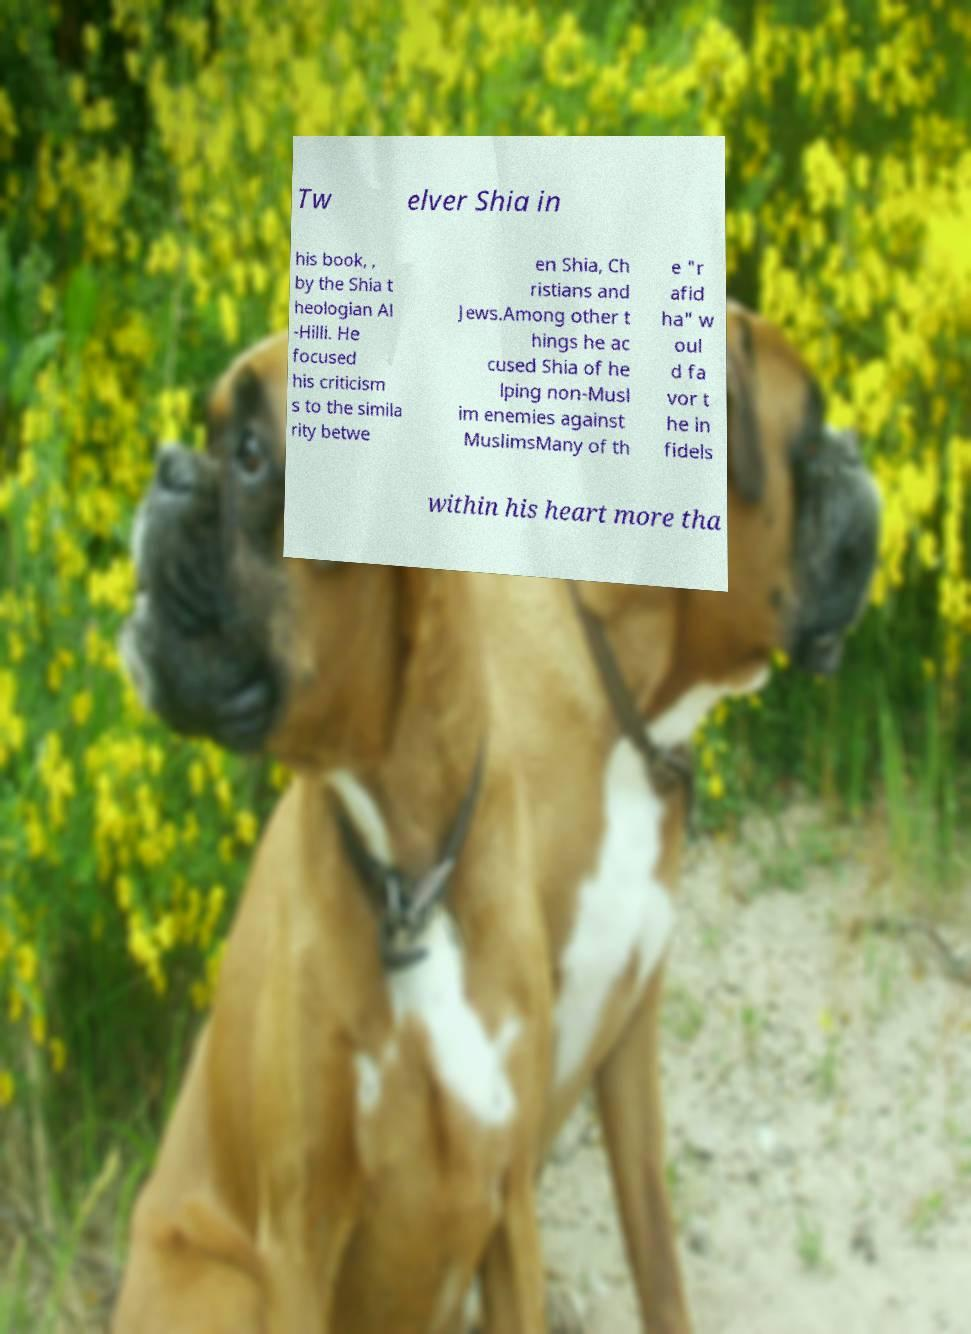Can you read and provide the text displayed in the image?This photo seems to have some interesting text. Can you extract and type it out for me? Tw elver Shia in his book, , by the Shia t heologian Al -Hilli. He focused his criticism s to the simila rity betwe en Shia, Ch ristians and Jews.Among other t hings he ac cused Shia of he lping non-Musl im enemies against MuslimsMany of th e "r afid ha" w oul d fa vor t he in fidels within his heart more tha 